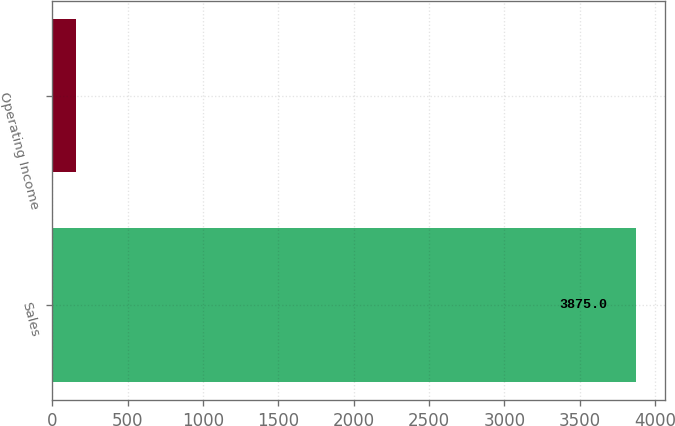Convert chart to OTSL. <chart><loc_0><loc_0><loc_500><loc_500><bar_chart><fcel>Sales<fcel>Operating Income<nl><fcel>3875<fcel>160<nl></chart> 